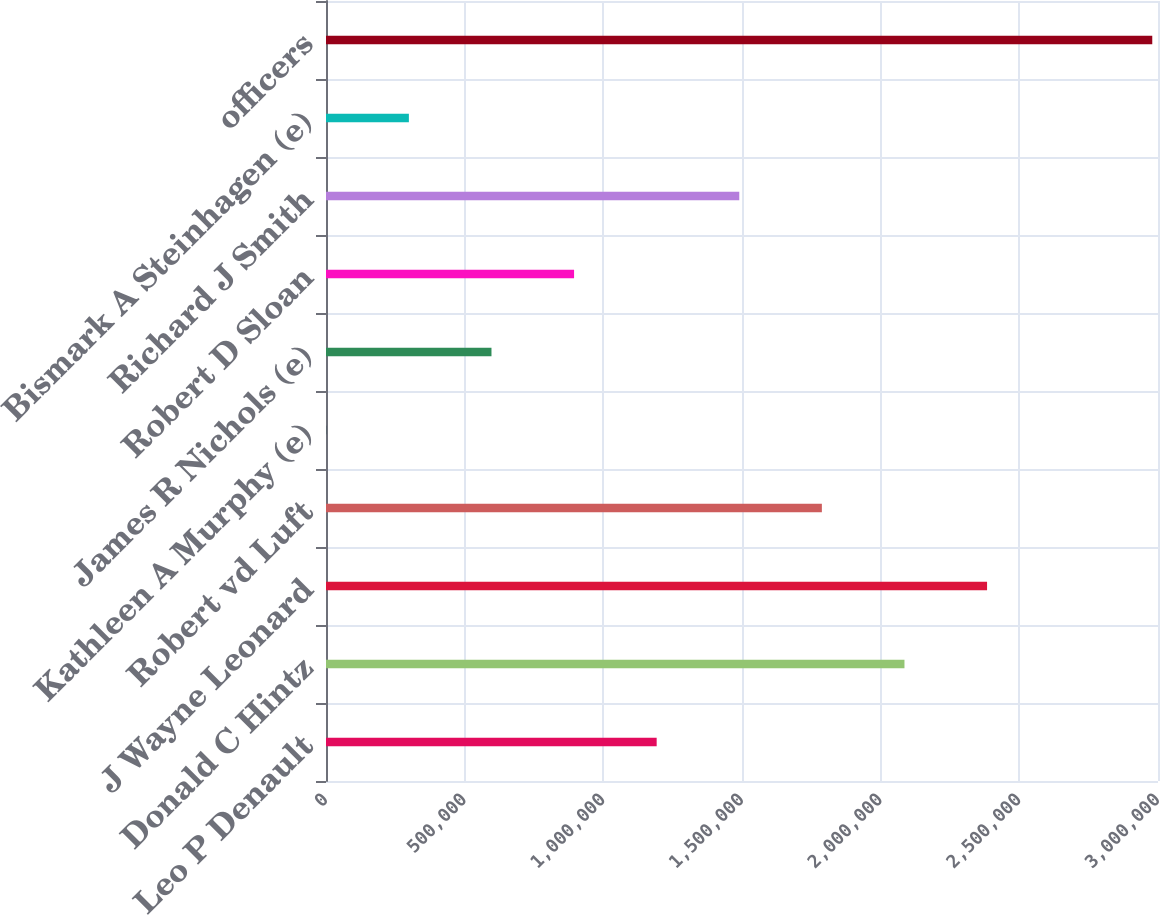<chart> <loc_0><loc_0><loc_500><loc_500><bar_chart><fcel>Leo P Denault<fcel>Donald C Hintz<fcel>J Wayne Leonard<fcel>Robert vd Luft<fcel>Kathleen A Murphy (e)<fcel>James R Nichols (e)<fcel>Robert D Sloan<fcel>Richard J Smith<fcel>Bismark A Steinhagen (e)<fcel>officers<nl><fcel>1.19233e+06<fcel>2.08582e+06<fcel>2.38365e+06<fcel>1.78799e+06<fcel>1000<fcel>596663<fcel>894494<fcel>1.49016e+06<fcel>298831<fcel>2.97931e+06<nl></chart> 